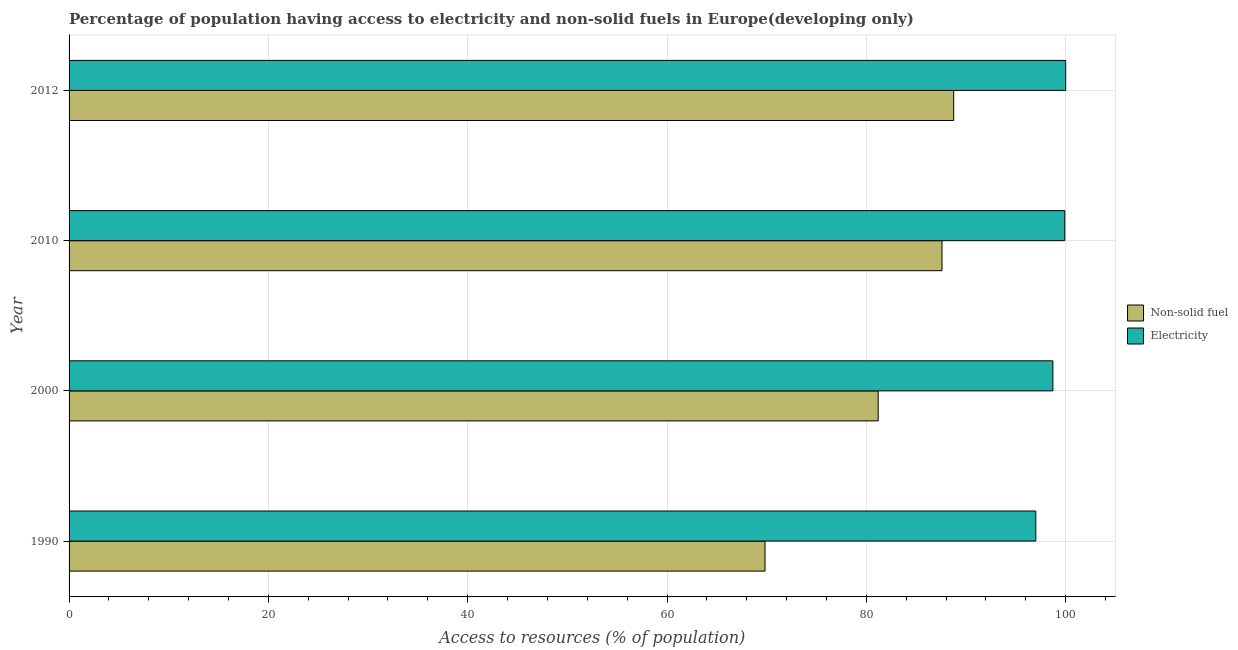How many different coloured bars are there?
Make the answer very short. 2. How many groups of bars are there?
Ensure brevity in your answer.  4. How many bars are there on the 4th tick from the bottom?
Your answer should be very brief. 2. In how many cases, is the number of bars for a given year not equal to the number of legend labels?
Your answer should be very brief. 0. What is the percentage of population having access to non-solid fuel in 2012?
Ensure brevity in your answer.  88.76. Across all years, what is the maximum percentage of population having access to non-solid fuel?
Offer a terse response. 88.76. Across all years, what is the minimum percentage of population having access to non-solid fuel?
Your answer should be very brief. 69.83. What is the total percentage of population having access to electricity in the graph?
Make the answer very short. 395.63. What is the difference between the percentage of population having access to non-solid fuel in 1990 and that in 2010?
Provide a short and direct response. -17.76. What is the difference between the percentage of population having access to non-solid fuel in 2000 and the percentage of population having access to electricity in 2010?
Offer a terse response. -18.73. What is the average percentage of population having access to non-solid fuel per year?
Offer a very short reply. 81.84. In the year 2000, what is the difference between the percentage of population having access to electricity and percentage of population having access to non-solid fuel?
Your response must be concise. 17.53. In how many years, is the percentage of population having access to electricity greater than 92 %?
Give a very brief answer. 4. What is the difference between the highest and the second highest percentage of population having access to non-solid fuel?
Make the answer very short. 1.18. Is the sum of the percentage of population having access to non-solid fuel in 1990 and 2010 greater than the maximum percentage of population having access to electricity across all years?
Give a very brief answer. Yes. What does the 1st bar from the top in 2010 represents?
Offer a very short reply. Electricity. What does the 1st bar from the bottom in 2000 represents?
Your answer should be very brief. Non-solid fuel. How many bars are there?
Offer a very short reply. 8. Are all the bars in the graph horizontal?
Ensure brevity in your answer.  Yes. What is the difference between two consecutive major ticks on the X-axis?
Your answer should be very brief. 20. Are the values on the major ticks of X-axis written in scientific E-notation?
Your answer should be very brief. No. Does the graph contain any zero values?
Give a very brief answer. No. Does the graph contain grids?
Provide a succinct answer. Yes. How many legend labels are there?
Keep it short and to the point. 2. What is the title of the graph?
Offer a very short reply. Percentage of population having access to electricity and non-solid fuels in Europe(developing only). What is the label or title of the X-axis?
Your response must be concise. Access to resources (% of population). What is the Access to resources (% of population) in Non-solid fuel in 1990?
Your response must be concise. 69.83. What is the Access to resources (% of population) in Electricity in 1990?
Offer a terse response. 97. What is the Access to resources (% of population) in Non-solid fuel in 2000?
Your answer should be compact. 81.18. What is the Access to resources (% of population) of Electricity in 2000?
Ensure brevity in your answer.  98.72. What is the Access to resources (% of population) in Non-solid fuel in 2010?
Ensure brevity in your answer.  87.59. What is the Access to resources (% of population) in Electricity in 2010?
Provide a succinct answer. 99.91. What is the Access to resources (% of population) in Non-solid fuel in 2012?
Ensure brevity in your answer.  88.76. What is the Access to resources (% of population) of Electricity in 2012?
Give a very brief answer. 100. Across all years, what is the maximum Access to resources (% of population) of Non-solid fuel?
Offer a terse response. 88.76. Across all years, what is the maximum Access to resources (% of population) in Electricity?
Make the answer very short. 100. Across all years, what is the minimum Access to resources (% of population) of Non-solid fuel?
Keep it short and to the point. 69.83. Across all years, what is the minimum Access to resources (% of population) in Electricity?
Offer a very short reply. 97. What is the total Access to resources (% of population) in Non-solid fuel in the graph?
Offer a terse response. 327.37. What is the total Access to resources (% of population) in Electricity in the graph?
Your answer should be compact. 395.63. What is the difference between the Access to resources (% of population) in Non-solid fuel in 1990 and that in 2000?
Your answer should be compact. -11.35. What is the difference between the Access to resources (% of population) in Electricity in 1990 and that in 2000?
Ensure brevity in your answer.  -1.71. What is the difference between the Access to resources (% of population) in Non-solid fuel in 1990 and that in 2010?
Your answer should be compact. -17.76. What is the difference between the Access to resources (% of population) of Electricity in 1990 and that in 2010?
Your answer should be compact. -2.91. What is the difference between the Access to resources (% of population) of Non-solid fuel in 1990 and that in 2012?
Offer a terse response. -18.93. What is the difference between the Access to resources (% of population) of Electricity in 1990 and that in 2012?
Offer a very short reply. -3. What is the difference between the Access to resources (% of population) of Non-solid fuel in 2000 and that in 2010?
Ensure brevity in your answer.  -6.4. What is the difference between the Access to resources (% of population) of Electricity in 2000 and that in 2010?
Give a very brief answer. -1.2. What is the difference between the Access to resources (% of population) in Non-solid fuel in 2000 and that in 2012?
Provide a short and direct response. -7.58. What is the difference between the Access to resources (% of population) of Electricity in 2000 and that in 2012?
Provide a succinct answer. -1.28. What is the difference between the Access to resources (% of population) in Non-solid fuel in 2010 and that in 2012?
Your answer should be very brief. -1.18. What is the difference between the Access to resources (% of population) of Electricity in 2010 and that in 2012?
Offer a terse response. -0.09. What is the difference between the Access to resources (% of population) of Non-solid fuel in 1990 and the Access to resources (% of population) of Electricity in 2000?
Your response must be concise. -28.88. What is the difference between the Access to resources (% of population) of Non-solid fuel in 1990 and the Access to resources (% of population) of Electricity in 2010?
Keep it short and to the point. -30.08. What is the difference between the Access to resources (% of population) in Non-solid fuel in 1990 and the Access to resources (% of population) in Electricity in 2012?
Provide a short and direct response. -30.17. What is the difference between the Access to resources (% of population) in Non-solid fuel in 2000 and the Access to resources (% of population) in Electricity in 2010?
Your response must be concise. -18.73. What is the difference between the Access to resources (% of population) of Non-solid fuel in 2000 and the Access to resources (% of population) of Electricity in 2012?
Offer a terse response. -18.82. What is the difference between the Access to resources (% of population) of Non-solid fuel in 2010 and the Access to resources (% of population) of Electricity in 2012?
Offer a terse response. -12.41. What is the average Access to resources (% of population) of Non-solid fuel per year?
Provide a short and direct response. 81.84. What is the average Access to resources (% of population) of Electricity per year?
Ensure brevity in your answer.  98.91. In the year 1990, what is the difference between the Access to resources (% of population) of Non-solid fuel and Access to resources (% of population) of Electricity?
Your answer should be compact. -27.17. In the year 2000, what is the difference between the Access to resources (% of population) in Non-solid fuel and Access to resources (% of population) in Electricity?
Make the answer very short. -17.53. In the year 2010, what is the difference between the Access to resources (% of population) of Non-solid fuel and Access to resources (% of population) of Electricity?
Your answer should be very brief. -12.32. In the year 2012, what is the difference between the Access to resources (% of population) of Non-solid fuel and Access to resources (% of population) of Electricity?
Your response must be concise. -11.24. What is the ratio of the Access to resources (% of population) in Non-solid fuel in 1990 to that in 2000?
Your answer should be compact. 0.86. What is the ratio of the Access to resources (% of population) of Electricity in 1990 to that in 2000?
Keep it short and to the point. 0.98. What is the ratio of the Access to resources (% of population) of Non-solid fuel in 1990 to that in 2010?
Offer a very short reply. 0.8. What is the ratio of the Access to resources (% of population) of Electricity in 1990 to that in 2010?
Offer a terse response. 0.97. What is the ratio of the Access to resources (% of population) of Non-solid fuel in 1990 to that in 2012?
Make the answer very short. 0.79. What is the ratio of the Access to resources (% of population) of Non-solid fuel in 2000 to that in 2010?
Give a very brief answer. 0.93. What is the ratio of the Access to resources (% of population) in Non-solid fuel in 2000 to that in 2012?
Your answer should be very brief. 0.91. What is the ratio of the Access to resources (% of population) of Electricity in 2000 to that in 2012?
Give a very brief answer. 0.99. What is the ratio of the Access to resources (% of population) in Non-solid fuel in 2010 to that in 2012?
Offer a terse response. 0.99. What is the difference between the highest and the second highest Access to resources (% of population) of Non-solid fuel?
Your answer should be compact. 1.18. What is the difference between the highest and the second highest Access to resources (% of population) in Electricity?
Your response must be concise. 0.09. What is the difference between the highest and the lowest Access to resources (% of population) in Non-solid fuel?
Provide a short and direct response. 18.93. What is the difference between the highest and the lowest Access to resources (% of population) in Electricity?
Give a very brief answer. 3. 